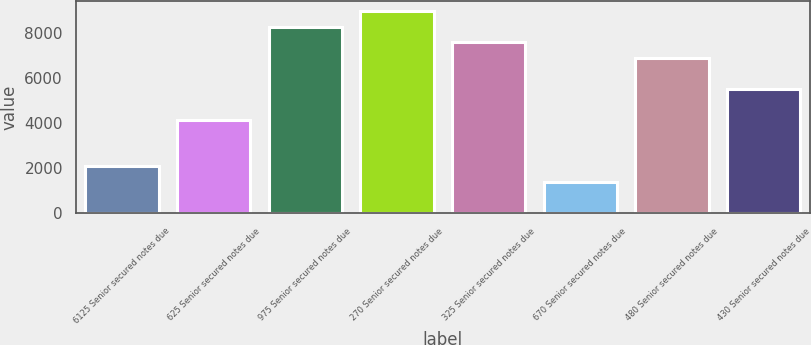<chart> <loc_0><loc_0><loc_500><loc_500><bar_chart><fcel>6125 Senior secured notes due<fcel>625 Senior secured notes due<fcel>975 Senior secured notes due<fcel>270 Senior secured notes due<fcel>325 Senior secured notes due<fcel>670 Senior secured notes due<fcel>480 Senior secured notes due<fcel>430 Senior secured notes due<nl><fcel>2075.9<fcel>4134.8<fcel>8252.6<fcel>8938.9<fcel>7566.3<fcel>1389.6<fcel>6880<fcel>5507.4<nl></chart> 